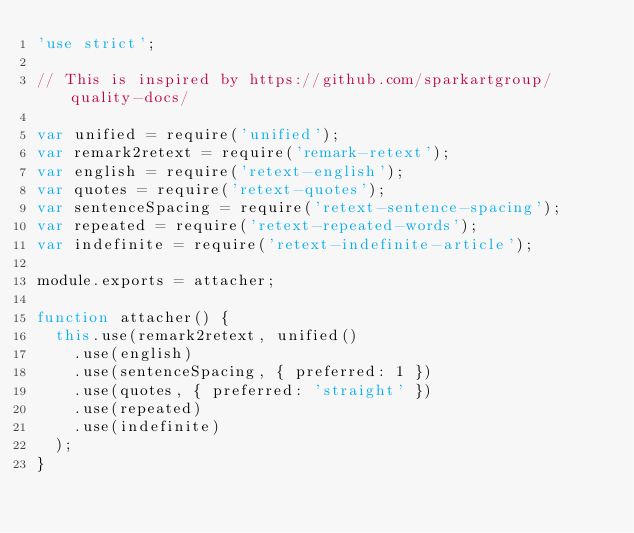<code> <loc_0><loc_0><loc_500><loc_500><_JavaScript_>'use strict';

// This is inspired by https://github.com/sparkartgroup/quality-docs/

var unified = require('unified');
var remark2retext = require('remark-retext');
var english = require('retext-english');
var quotes = require('retext-quotes');
var sentenceSpacing = require('retext-sentence-spacing');
var repeated = require('retext-repeated-words');
var indefinite = require('retext-indefinite-article');

module.exports = attacher;

function attacher() {
  this.use(remark2retext, unified()
    .use(english)
    .use(sentenceSpacing, { preferred: 1 })
    .use(quotes, { preferred: 'straight' })
    .use(repeated)
    .use(indefinite)
  );
}
</code> 